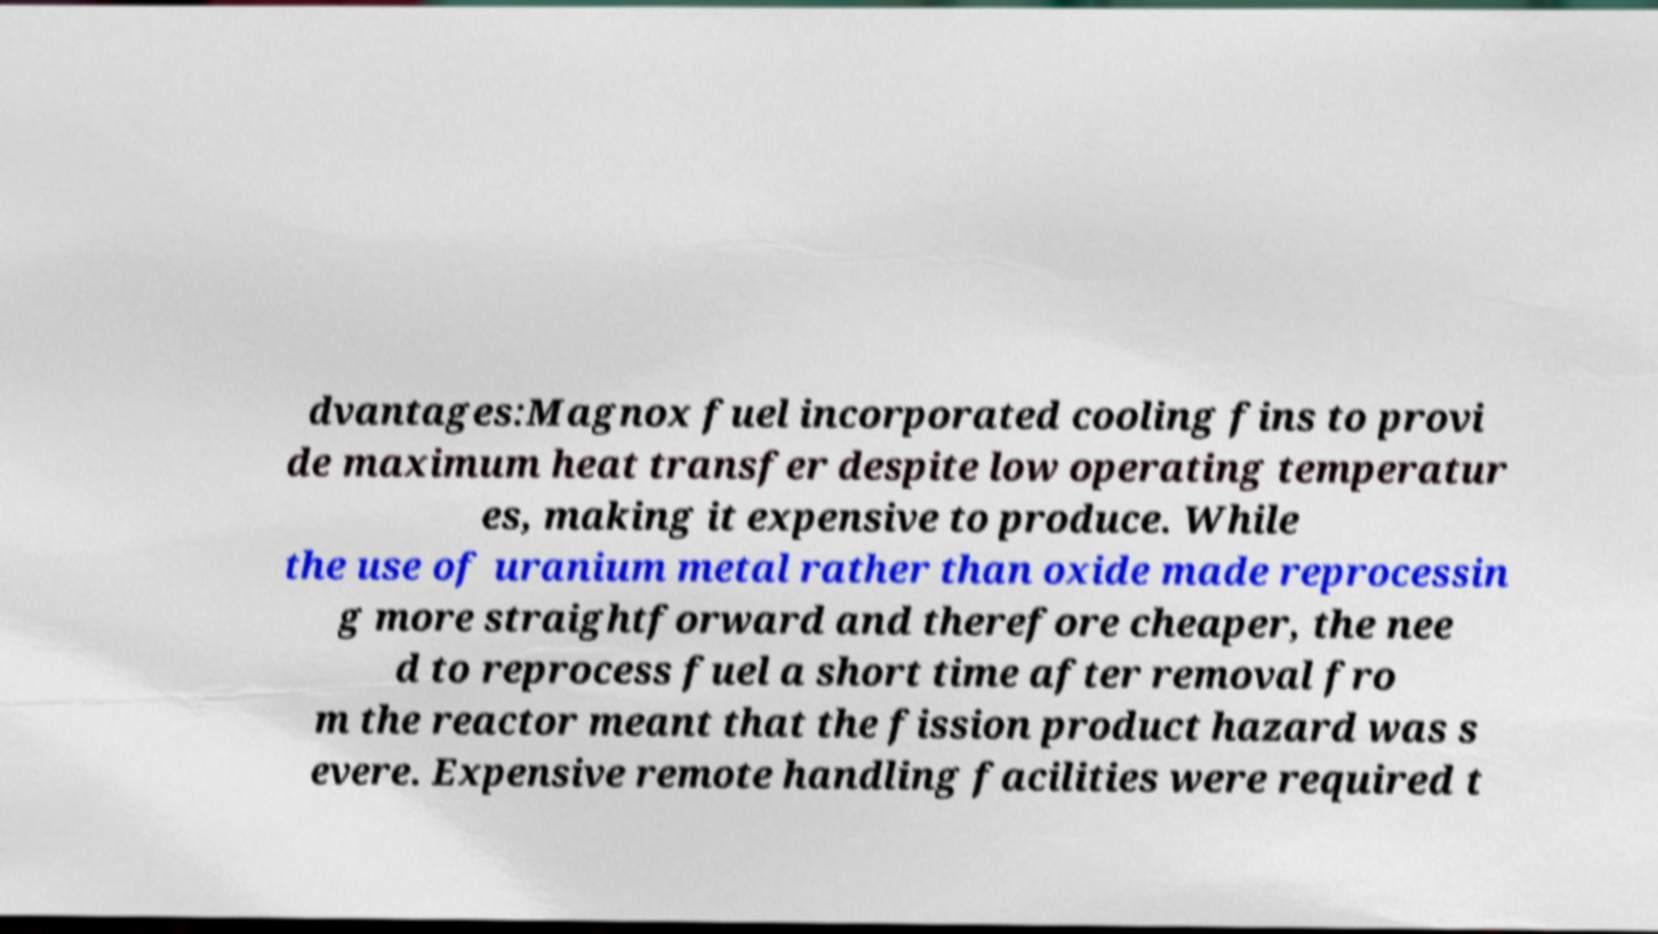Could you assist in decoding the text presented in this image and type it out clearly? dvantages:Magnox fuel incorporated cooling fins to provi de maximum heat transfer despite low operating temperatur es, making it expensive to produce. While the use of uranium metal rather than oxide made reprocessin g more straightforward and therefore cheaper, the nee d to reprocess fuel a short time after removal fro m the reactor meant that the fission product hazard was s evere. Expensive remote handling facilities were required t 